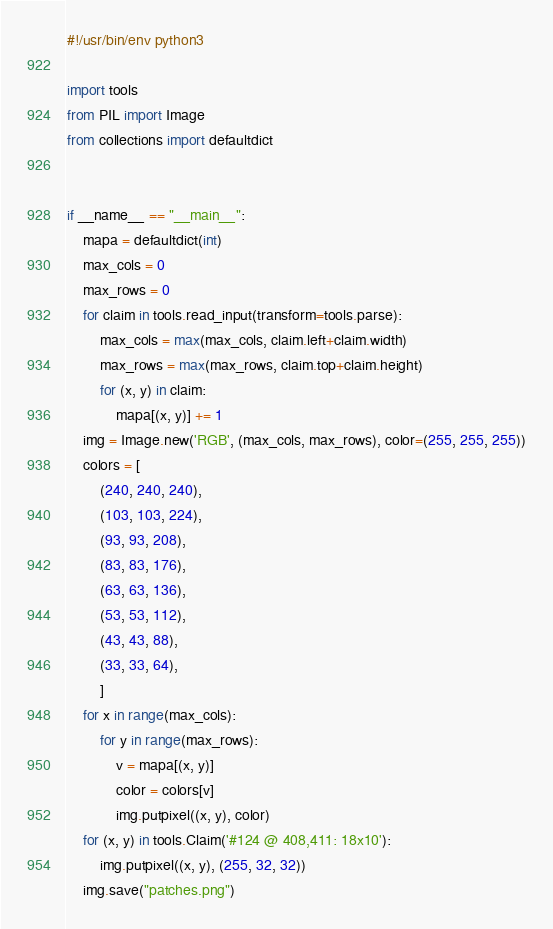Convert code to text. <code><loc_0><loc_0><loc_500><loc_500><_Python_>#!/usr/bin/env python3

import tools
from PIL import Image
from collections import defaultdict


if __name__ == "__main__":
    mapa = defaultdict(int)
    max_cols = 0
    max_rows = 0
    for claim in tools.read_input(transform=tools.parse):
        max_cols = max(max_cols, claim.left+claim.width)
        max_rows = max(max_rows, claim.top+claim.height)
        for (x, y) in claim:
            mapa[(x, y)] += 1
    img = Image.new('RGB', (max_cols, max_rows), color=(255, 255, 255))
    colors = [
        (240, 240, 240),
        (103, 103, 224),
        (93, 93, 208),
        (83, 83, 176),
        (63, 63, 136),
        (53, 53, 112),
        (43, 43, 88),
        (33, 33, 64),
        ]
    for x in range(max_cols):
        for y in range(max_rows):
            v = mapa[(x, y)]
            color = colors[v]
            img.putpixel((x, y), color)
    for (x, y) in tools.Claim('#124 @ 408,411: 18x10'):
        img.putpixel((x, y), (255, 32, 32))
    img.save("patches.png")
</code> 